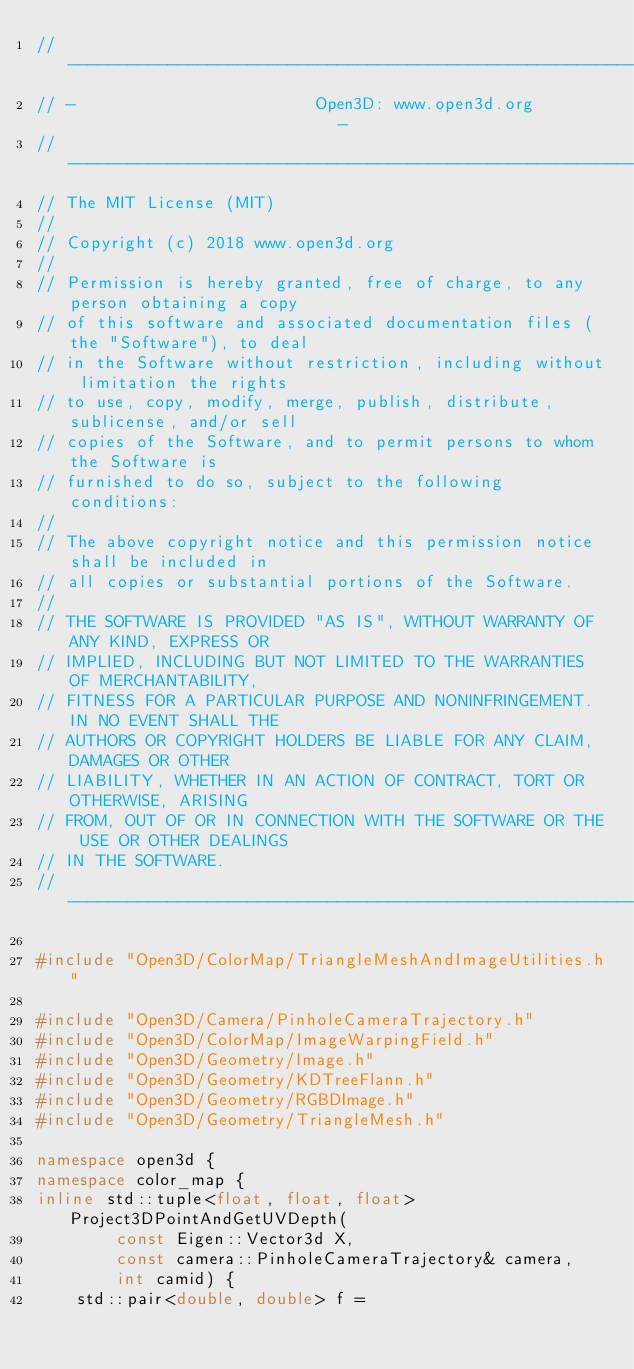Convert code to text. <code><loc_0><loc_0><loc_500><loc_500><_C++_>// ----------------------------------------------------------------------------
// -                        Open3D: www.open3d.org                            -
// ----------------------------------------------------------------------------
// The MIT License (MIT)
//
// Copyright (c) 2018 www.open3d.org
//
// Permission is hereby granted, free of charge, to any person obtaining a copy
// of this software and associated documentation files (the "Software"), to deal
// in the Software without restriction, including without limitation the rights
// to use, copy, modify, merge, publish, distribute, sublicense, and/or sell
// copies of the Software, and to permit persons to whom the Software is
// furnished to do so, subject to the following conditions:
//
// The above copyright notice and this permission notice shall be included in
// all copies or substantial portions of the Software.
//
// THE SOFTWARE IS PROVIDED "AS IS", WITHOUT WARRANTY OF ANY KIND, EXPRESS OR
// IMPLIED, INCLUDING BUT NOT LIMITED TO THE WARRANTIES OF MERCHANTABILITY,
// FITNESS FOR A PARTICULAR PURPOSE AND NONINFRINGEMENT. IN NO EVENT SHALL THE
// AUTHORS OR COPYRIGHT HOLDERS BE LIABLE FOR ANY CLAIM, DAMAGES OR OTHER
// LIABILITY, WHETHER IN AN ACTION OF CONTRACT, TORT OR OTHERWISE, ARISING
// FROM, OUT OF OR IN CONNECTION WITH THE SOFTWARE OR THE USE OR OTHER DEALINGS
// IN THE SOFTWARE.
// ----------------------------------------------------------------------------

#include "Open3D/ColorMap/TriangleMeshAndImageUtilities.h"

#include "Open3D/Camera/PinholeCameraTrajectory.h"
#include "Open3D/ColorMap/ImageWarpingField.h"
#include "Open3D/Geometry/Image.h"
#include "Open3D/Geometry/KDTreeFlann.h"
#include "Open3D/Geometry/RGBDImage.h"
#include "Open3D/Geometry/TriangleMesh.h"

namespace open3d {
namespace color_map {
inline std::tuple<float, float, float> Project3DPointAndGetUVDepth(
        const Eigen::Vector3d X,
        const camera::PinholeCameraTrajectory& camera,
        int camid) {
    std::pair<double, double> f =</code> 